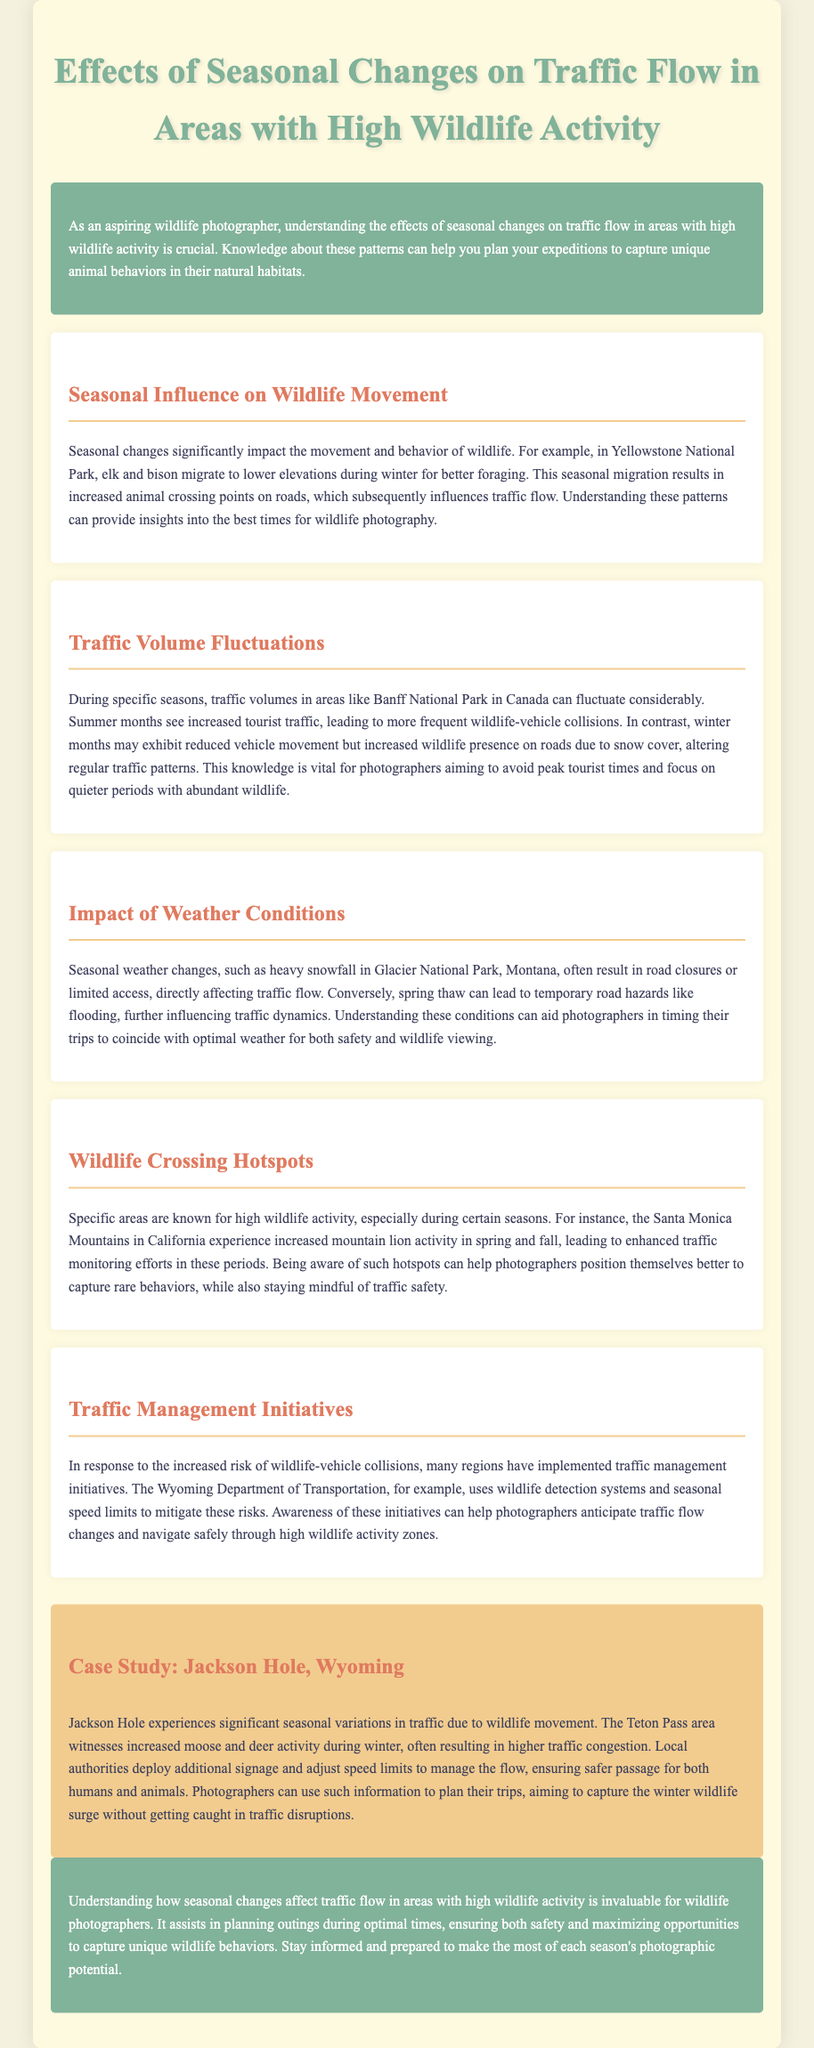what is the title of the report? The title of the report is explicitly stated at the beginning of the document.
Answer: Effects of Seasonal Changes on Traffic Flow in Areas with High Wildlife Activity which national park experiences increased elk and bison migration during winter? The document mentions Yellowstone National Park as experiencing this migration.
Answer: Yellowstone National Park what effect does summer have on tourist traffic in Banff National Park? The report details that summer months see increased tourist traffic, affecting wildlife-vehicle collisions.
Answer: Increased tourist traffic what weather condition often causes road closures in Glacier National Park? Heavy snowfall in winter is described as causing road closures.
Answer: Heavy snowfall which wildlife activity spikes in the Santa Monica Mountains during spring? The report notes an increase in mountain lion activity during this season.
Answer: Mountain lion activity what traffic management initiative is mentioned regarding wildlife detection? The document specifies the use of wildlife detection systems as a traffic management initiative.
Answer: Wildlife detection systems what is one of the changes in traffic flow during winter in Jackson Hole? The case study describes higher traffic congestion due to increased moose and deer activity during winter.
Answer: Higher traffic congestion how do seasonal changes influence wildlife behavior? Seasonal changes are noted to have significant impacts on the movement and behavior of wildlife.
Answer: Significant impacts what is the purpose of traffic management initiatives in high wildlife activity areas? The document explains that these initiatives aim to mitigate the risks of wildlife-vehicle collisions.
Answer: Mitigate risks of wildlife-vehicle collisions 